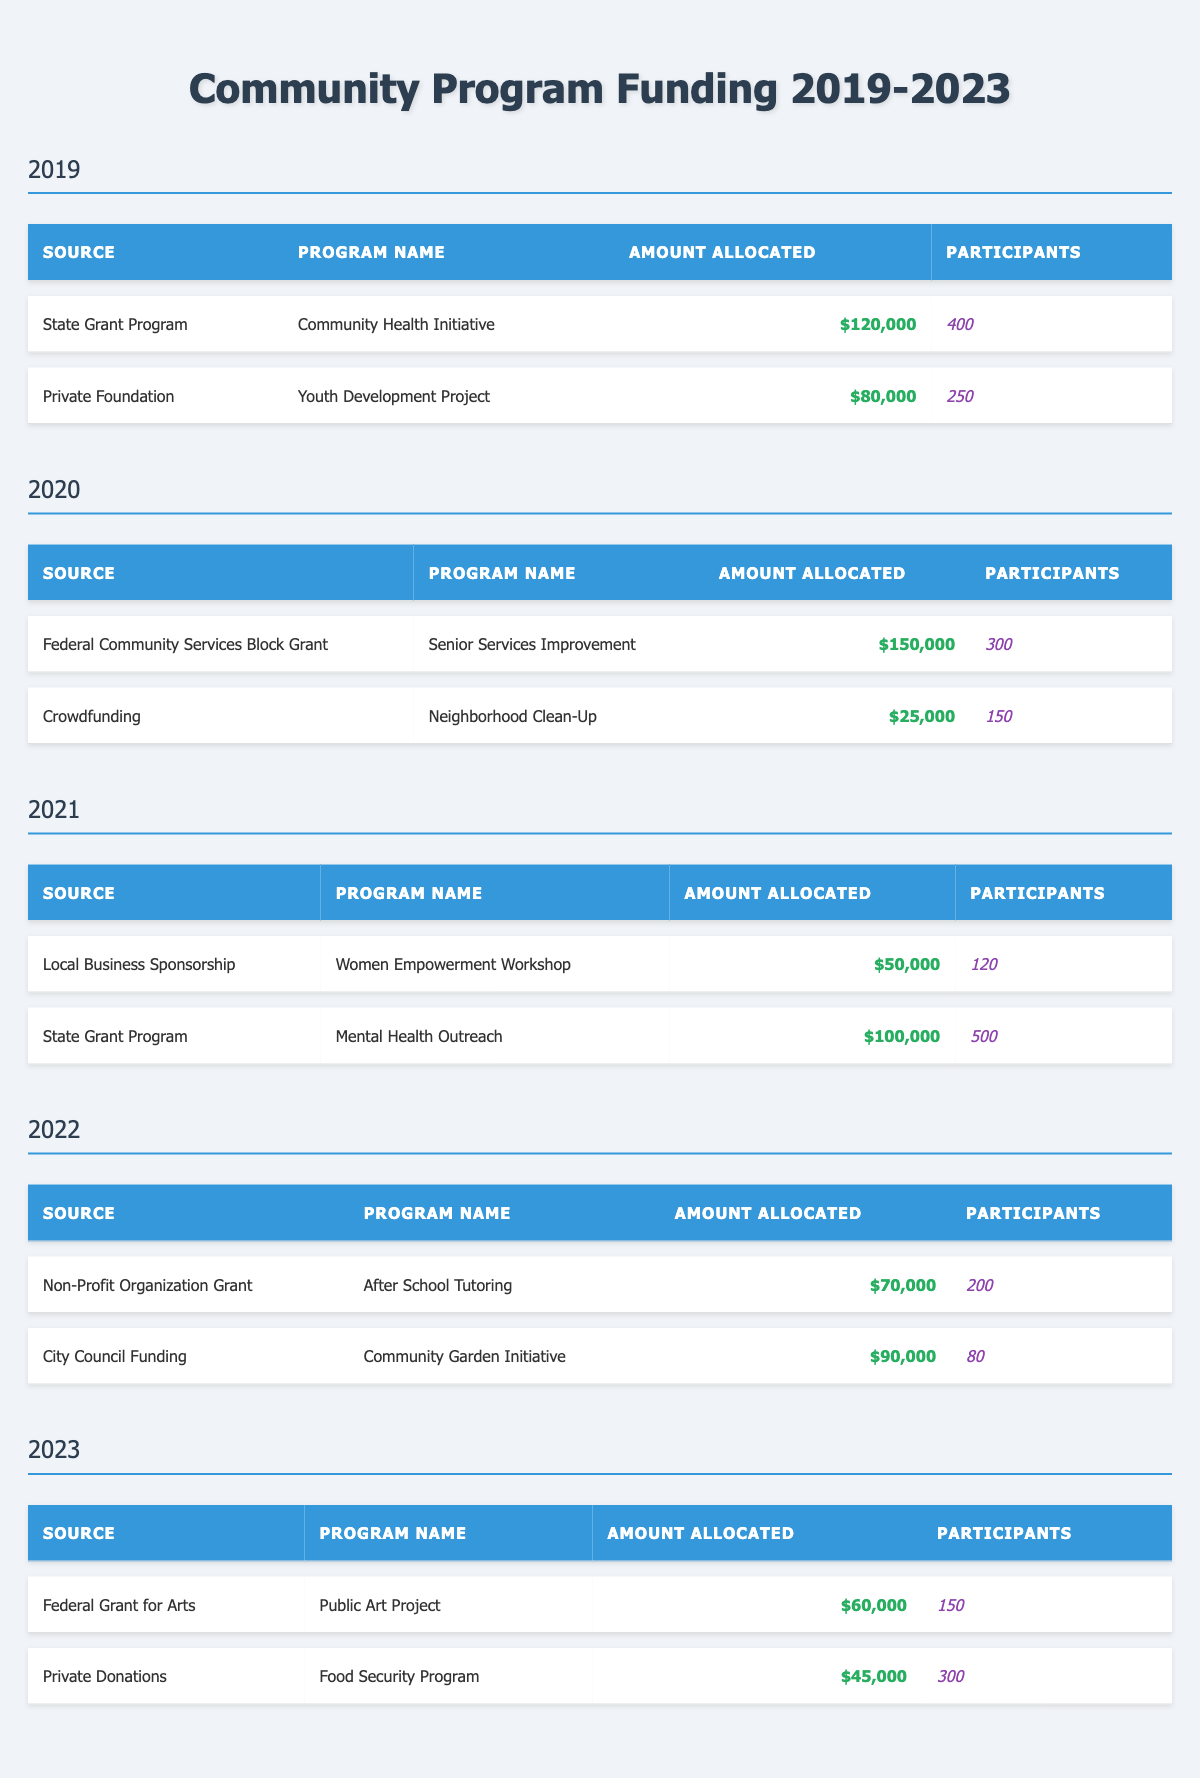What is the total amount allocated for community programs in 2022? To find the total for 2022, I add the amounts allocated for the programs listed for that year: $70,000 (After School Tutoring) + $90,000 (Community Garden Initiative) = $160,000.
Answer: $160,000 Which funding source allocated the highest amount in 2020? By comparing the amounts allocated in 2020, Federal Community Services Block Grant allocated $150,000 (Senior Services Improvement), and Crowdfunding allocated $25,000 (Neighborhood Clean-Up). The highest is $150,000.
Answer: $150,000 How many participants were involved in the "Mental Health Outreach" program? The "Mental Health Outreach" program is listed under the State Grant Program for 2021, and it shows there were 500 participants.
Answer: 500 What is the average amount allocated per program in 2021? In 2021, there are two programs, with amounts of $50,000 (Women Empowerment Workshop) and $100,000 (Mental Health Outreach). The sum is $150,000, and with two programs, the average is $150,000 / 2 = $75,000.
Answer: $75,000 Was there a program funded by crowdfunding between 2019 and 2021? The table shows that crowdfunding was used as a funding source in 2020 for the Neighborhood Clean-Up program, therefore there was indeed a program funded by crowdfunding during these years.
Answer: Yes What is the total number of participants across all programs in 2023? In 2023, there are two programs: Public Art Project with 150 participants and Food Security Program with 300 participants. Adding those gives 150 + 300 = 450 participants in total.
Answer: 450 Which year had the highest total funding allocation? To find this, I first calculate the total allocations for each year: 2019: $120,000 + $80,000 = $200,000; 2020: $150,000 + $25,000 = $175,000; 2021: $50,000 + $100,000 = $150,000; 2022: $70,000 + $90,000 = $160,000; 2023: $60,000 + $45,000 = $105,000. The highest total is in 2019 with $200,000.
Answer: 2019 What percentage of the total funding in 2022 was allocated to the Community Garden Initiative? The total funding for 2022 is $160,000. The Community Garden Initiative was allocated $90,000. To find the percentage, (90,000 / 160,000) * 100 = 56.25%.
Answer: 56.25% How many programs in total were funded by the State Grant Program across the five years? The State Grant Program funded a total of three programs: Community Health Initiative in 2019, Mental Health Outreach in 2021, and one year with no duplication, so three unique programs total.
Answer: 3 Which program had the least number of participants, and how many were involved? By reviewing the participant counts, the Community Garden Initiative in 2022 had the least participants with just 80.
Answer: 80 